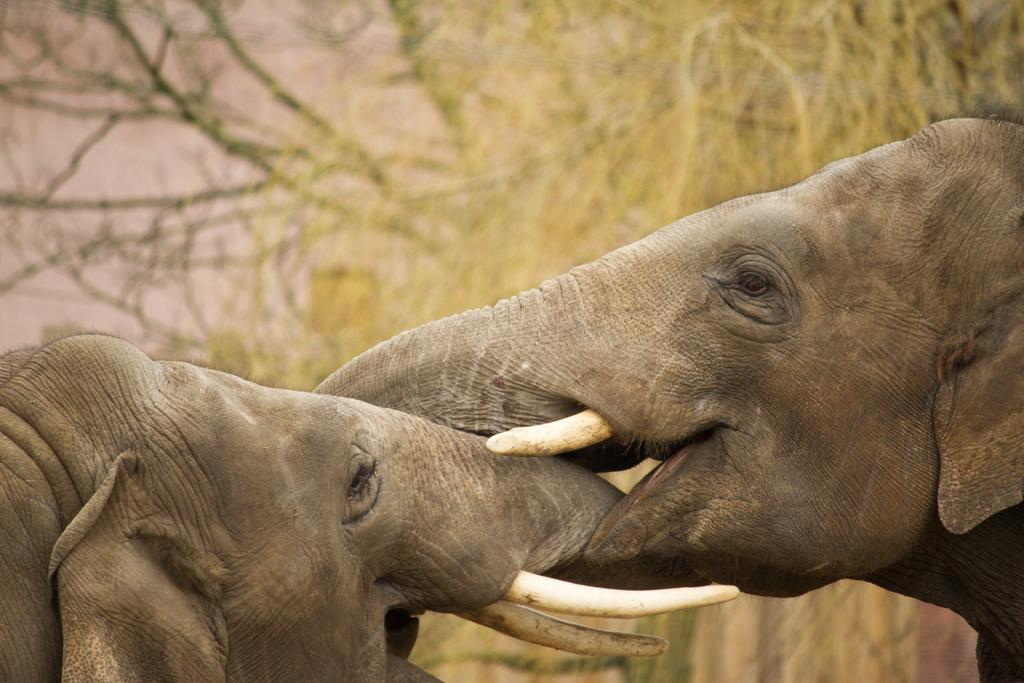How many elephants are present in the image? There are two elephants in the image. What can be seen in the background of the image? There are trees in the background of the image. Where is the cast of goldfish located in the image? There is no cast of goldfish present in the image. What type of water body can be seen in the image? There is no water body, such as a lake, present in the image. 